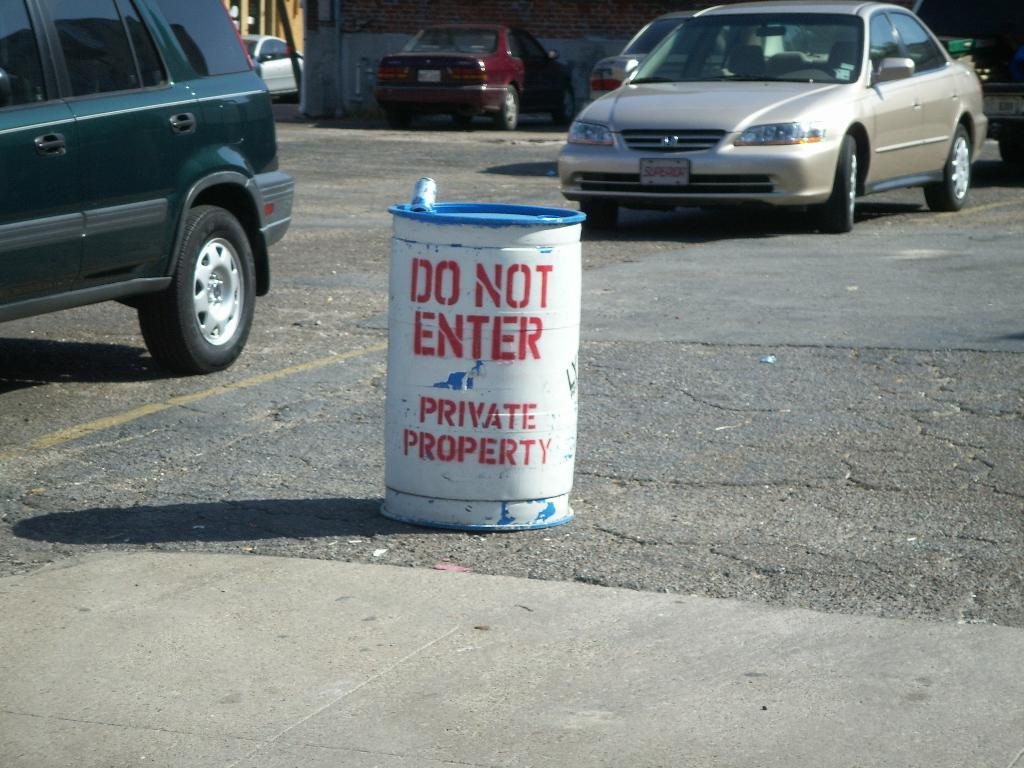<image>
Give a short and clear explanation of the subsequent image. Two cars and a can that says do not enter, private property. 